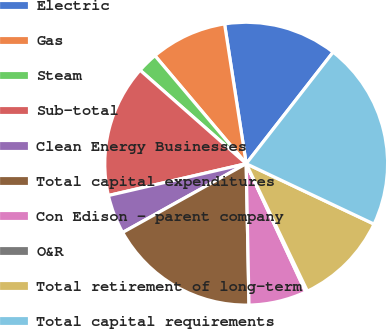Convert chart to OTSL. <chart><loc_0><loc_0><loc_500><loc_500><pie_chart><fcel>Electric<fcel>Gas<fcel>Steam<fcel>Sub-total<fcel>Clean Energy Businesses<fcel>Total capital expenditures<fcel>Con Edison - parent company<fcel>O&R<fcel>Total retirement of long-term<fcel>Total capital requirements<nl><fcel>12.98%<fcel>8.72%<fcel>2.34%<fcel>15.11%<fcel>4.47%<fcel>17.23%<fcel>6.6%<fcel>0.21%<fcel>10.85%<fcel>21.49%<nl></chart> 